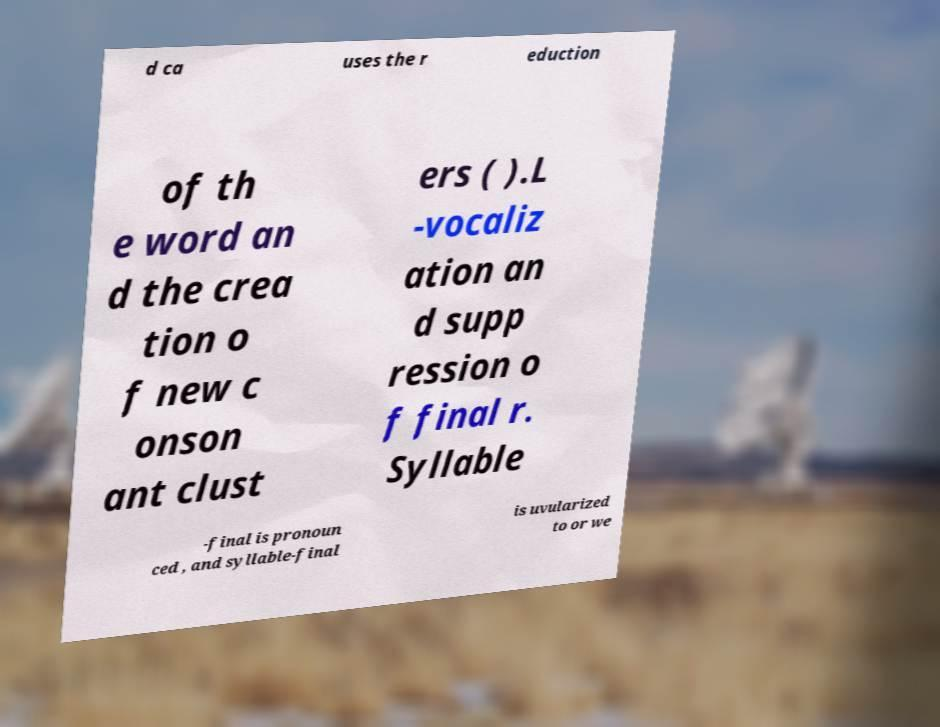For documentation purposes, I need the text within this image transcribed. Could you provide that? d ca uses the r eduction of th e word an d the crea tion o f new c onson ant clust ers ( ).L -vocaliz ation an d supp ression o f final r. Syllable -final is pronoun ced , and syllable-final is uvularized to or we 